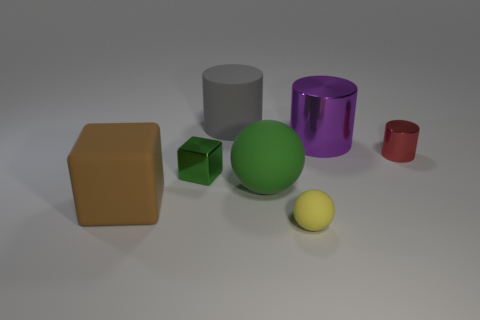Subtract all brown blocks. Subtract all yellow cylinders. How many blocks are left? 1 Add 2 yellow cubes. How many objects exist? 9 Subtract all blocks. How many objects are left? 5 Add 4 small purple cylinders. How many small purple cylinders exist? 4 Subtract 1 green blocks. How many objects are left? 6 Subtract all tiny brown things. Subtract all big objects. How many objects are left? 3 Add 6 gray rubber things. How many gray rubber things are left? 7 